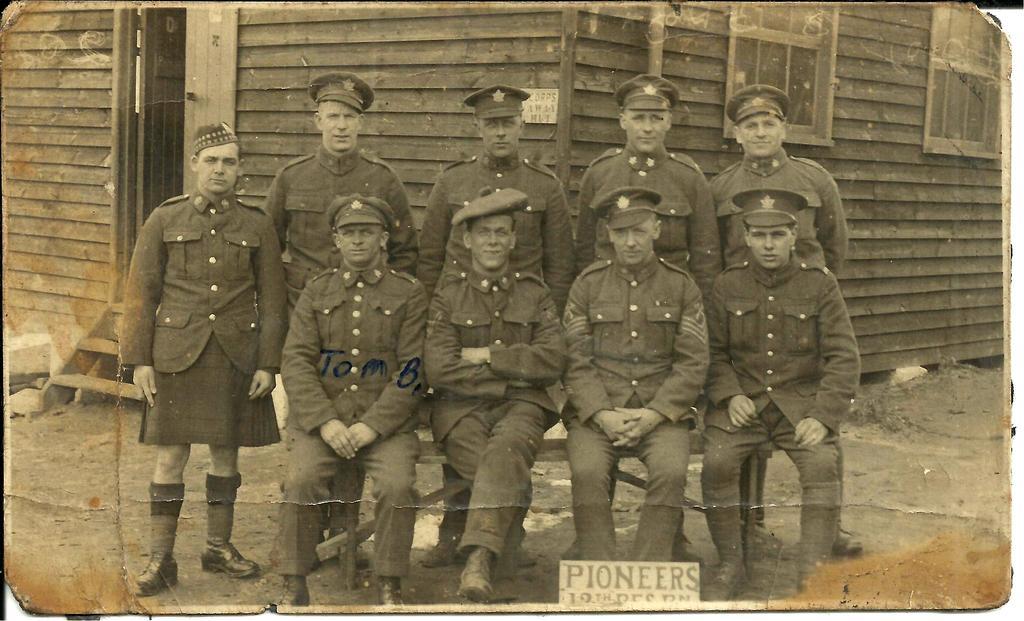How would you summarize this image in a sentence or two? In this image we can see a photograph. In the center of the image there are people standing and some of them are sitting. In the background there is a shed. At the bottom we can see a text. 